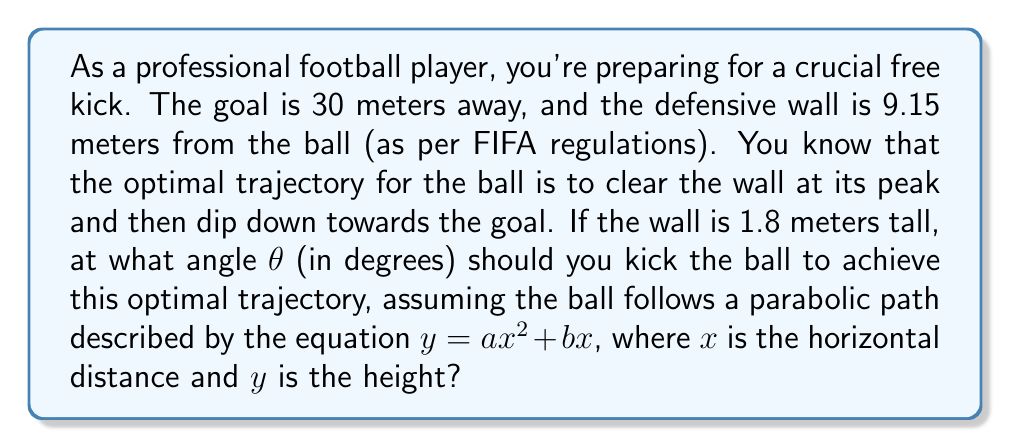What is the answer to this math problem? Let's approach this step-by-step:

1) The parabolic equation of the ball's trajectory is $y = ax^2 + bx$, where $a < 0$ for the downward curve.

2) We know two points on this curve:
   - At the wall: $x = 9.15$, $y = 1.8$
   - At the goal: $x = 30$, $y = 0$

3) Substituting these points into the equation:
   $1.8 = a(9.15)^2 + b(9.15)$
   $0 = a(30)^2 + b(30)$

4) From the second equation: $b = -30a$

5) Substituting this into the first equation:
   $1.8 = a(9.15)^2 - 30a(9.15)$
   $1.8 = 83.7225a - 274.5a$
   $1.8 = -190.7775a$
   $a = -0.00944$

6) Now we have $b = -30a = 0.2832$

7) The angle θ at which the ball is kicked is the initial slope of the parabola. This is given by the derivative of $y$ with respect to $x$ at $x = 0$:

   $\frac{dy}{dx} = 2ax + b$
   At $x = 0$: $\frac{dy}{dx} = b = 0.2832$

8) The angle θ is the inverse tangent of this slope:
   $θ = \tan^{-1}(0.2832)$

9) Converting to degrees:
   $θ = \tan^{-1}(0.2832) \cdot \frac{180}{\pi} ≈ 15.80°$
Answer: The optimal angle for the free kick is approximately 15.80°. 